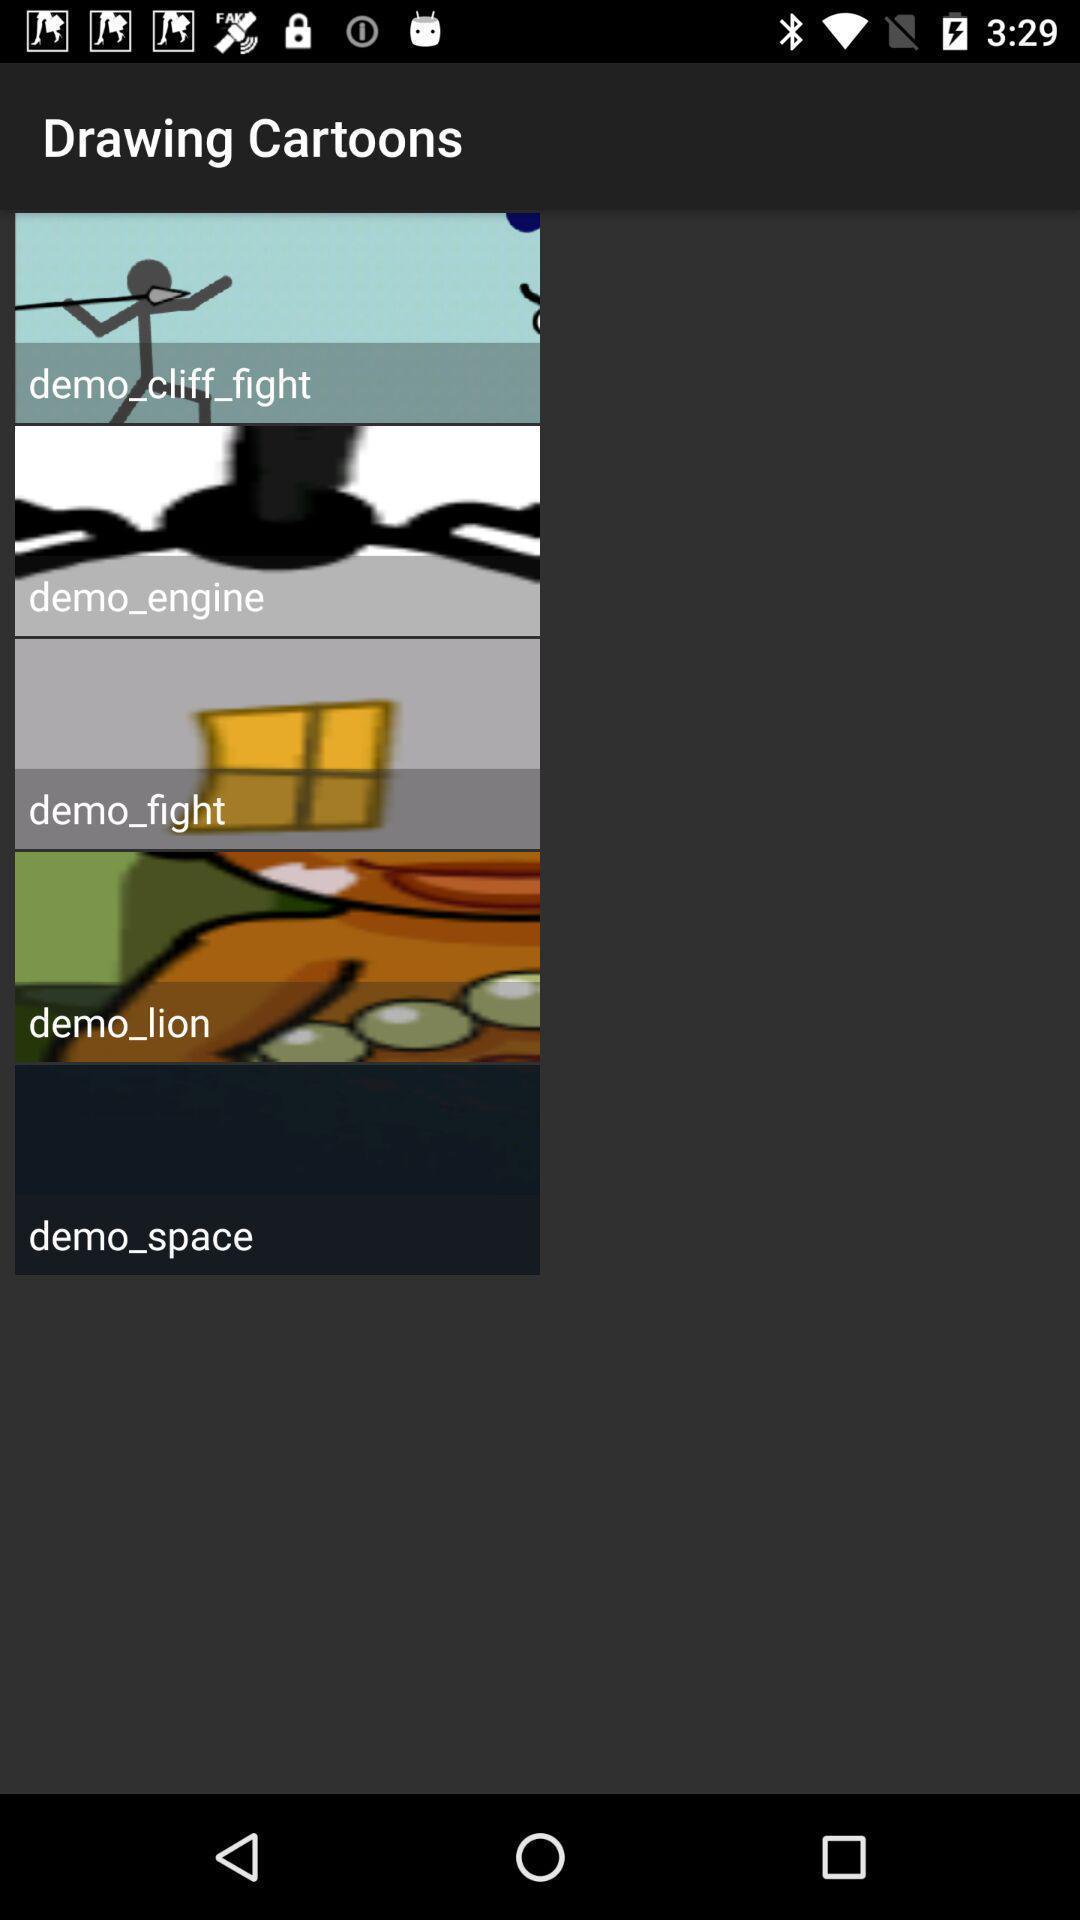Give me a summary of this screen capture. Screen displaying pictures of cartoons. 